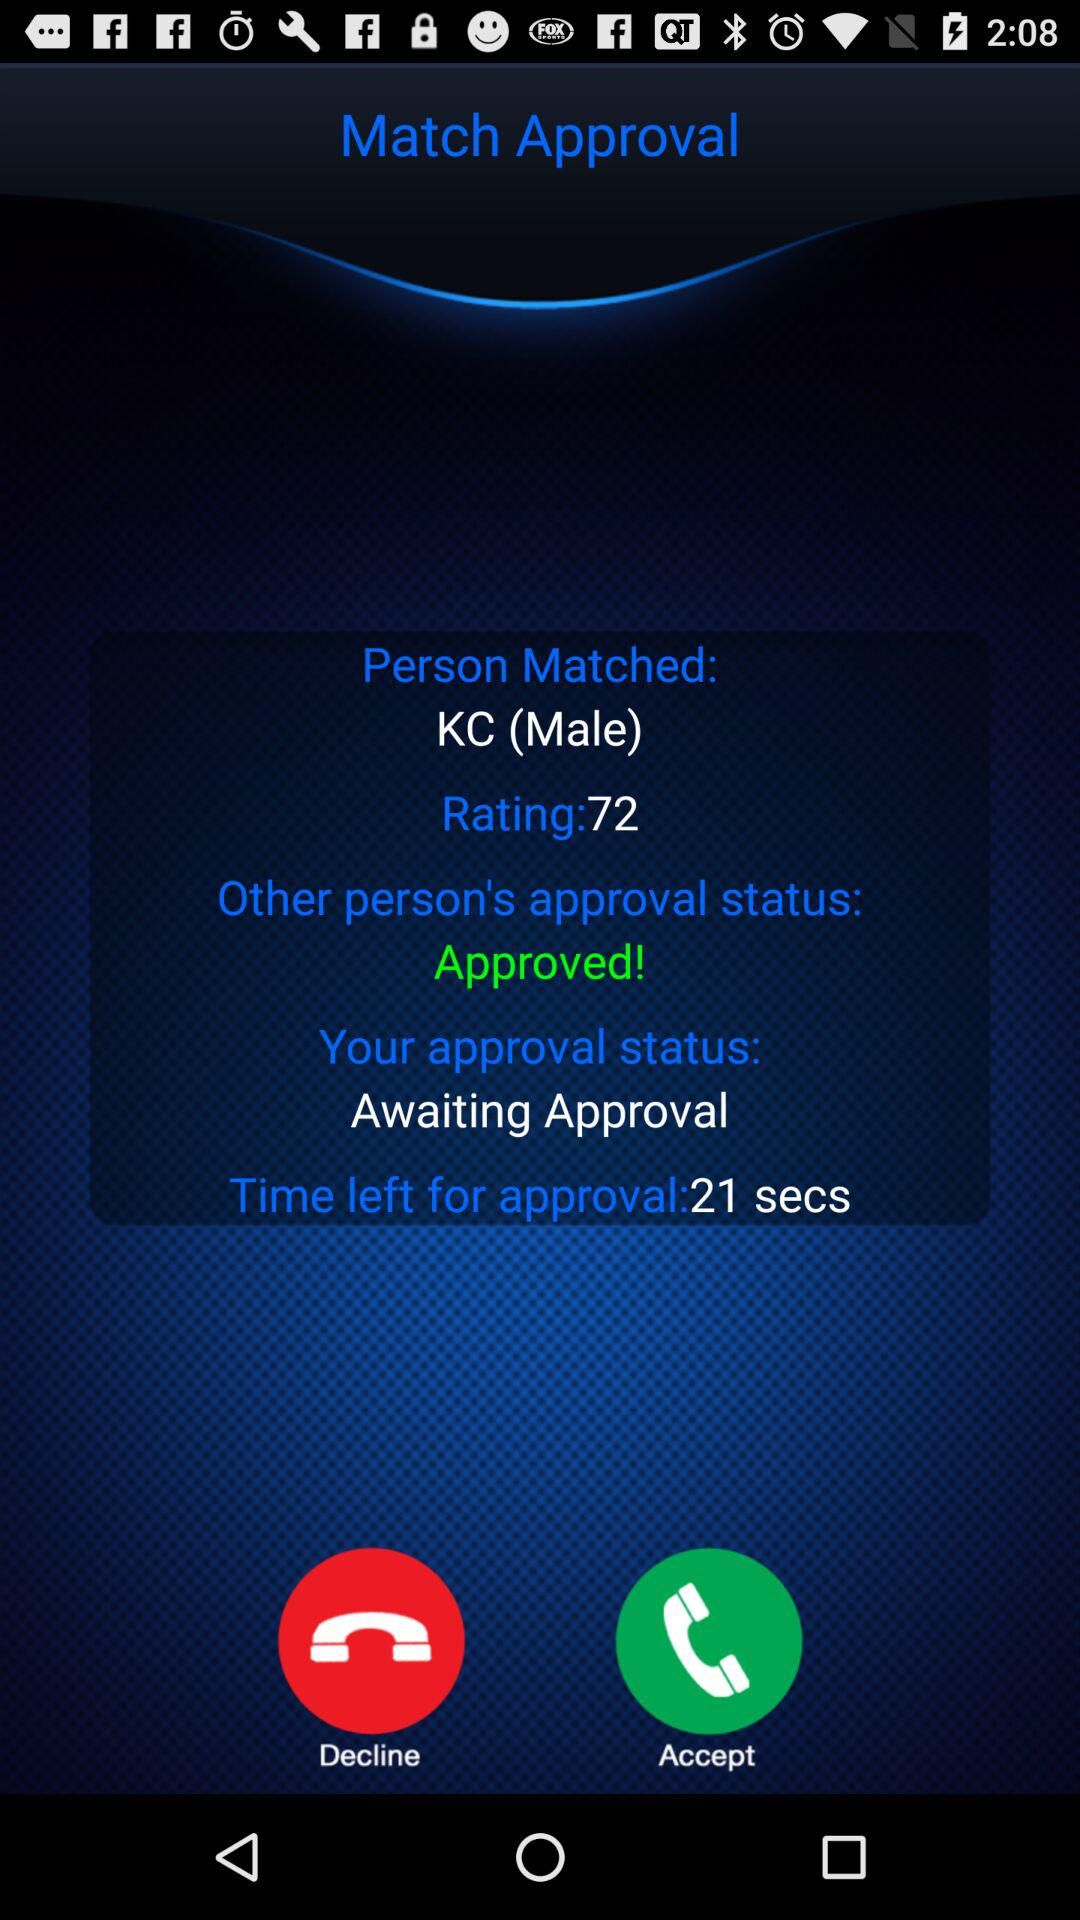What is the rating? The rating is 72. 